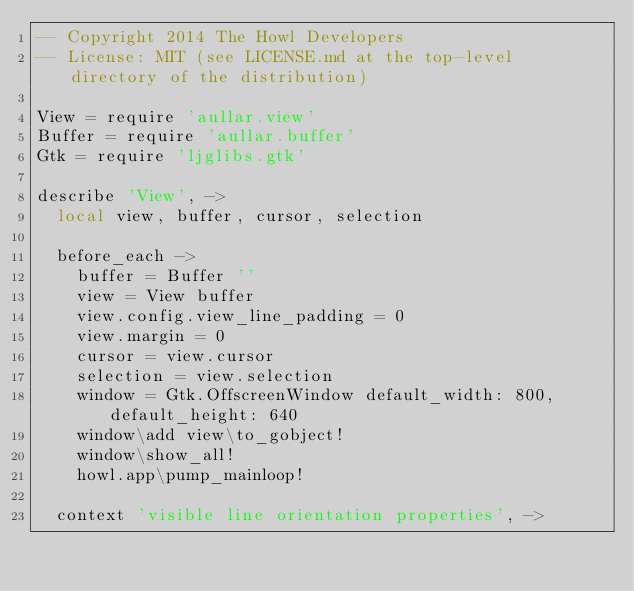Convert code to text. <code><loc_0><loc_0><loc_500><loc_500><_MoonScript_>-- Copyright 2014 The Howl Developers
-- License: MIT (see LICENSE.md at the top-level directory of the distribution)

View = require 'aullar.view'
Buffer = require 'aullar.buffer'
Gtk = require 'ljglibs.gtk'

describe 'View', ->
  local view, buffer, cursor, selection

  before_each ->
    buffer = Buffer ''
    view = View buffer
    view.config.view_line_padding = 0
    view.margin = 0
    cursor = view.cursor
    selection = view.selection
    window = Gtk.OffscreenWindow default_width: 800, default_height: 640
    window\add view\to_gobject!
    window\show_all!
    howl.app\pump_mainloop!

  context 'visible line orientation properties', -></code> 